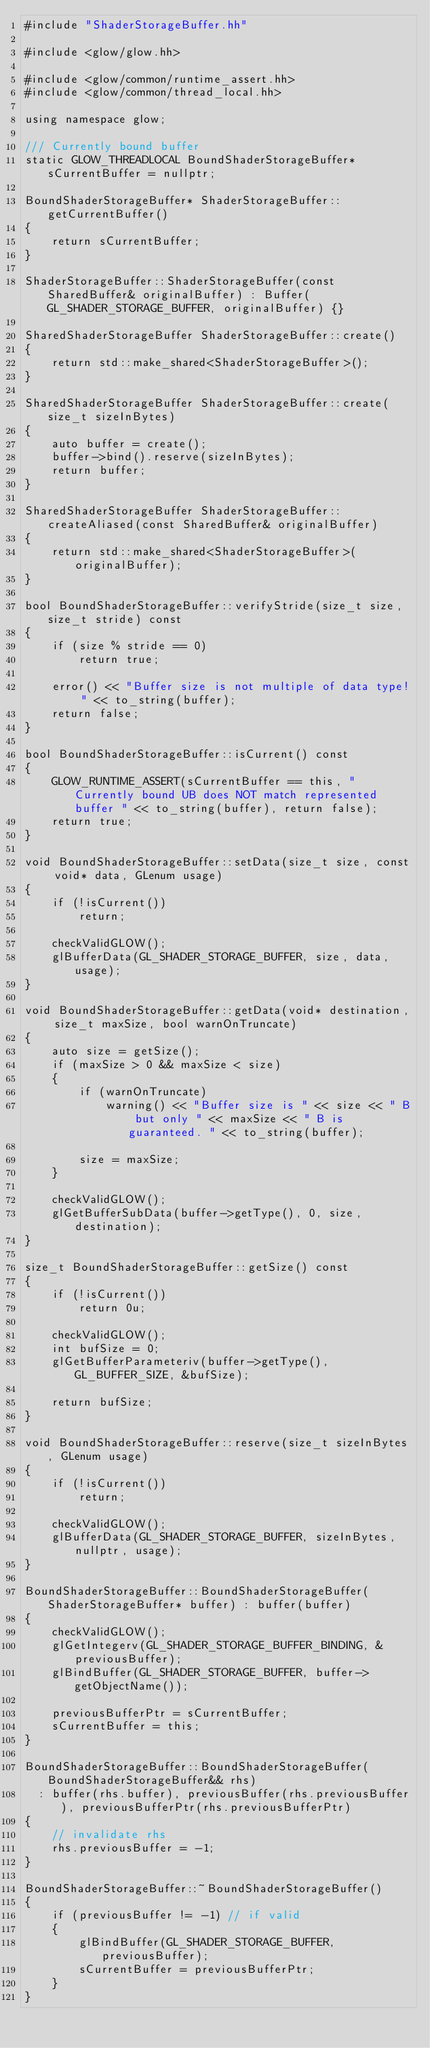<code> <loc_0><loc_0><loc_500><loc_500><_C++_>#include "ShaderStorageBuffer.hh"

#include <glow/glow.hh>

#include <glow/common/runtime_assert.hh>
#include <glow/common/thread_local.hh>

using namespace glow;

/// Currently bound buffer
static GLOW_THREADLOCAL BoundShaderStorageBuffer* sCurrentBuffer = nullptr;

BoundShaderStorageBuffer* ShaderStorageBuffer::getCurrentBuffer()
{
    return sCurrentBuffer;
}

ShaderStorageBuffer::ShaderStorageBuffer(const SharedBuffer& originalBuffer) : Buffer(GL_SHADER_STORAGE_BUFFER, originalBuffer) {}

SharedShaderStorageBuffer ShaderStorageBuffer::create()
{
    return std::make_shared<ShaderStorageBuffer>();
}

SharedShaderStorageBuffer ShaderStorageBuffer::create(size_t sizeInBytes)
{
    auto buffer = create();
    buffer->bind().reserve(sizeInBytes);
    return buffer;
}

SharedShaderStorageBuffer ShaderStorageBuffer::createAliased(const SharedBuffer& originalBuffer)
{
    return std::make_shared<ShaderStorageBuffer>(originalBuffer);
}

bool BoundShaderStorageBuffer::verifyStride(size_t size, size_t stride) const
{
    if (size % stride == 0)
        return true;

    error() << "Buffer size is not multiple of data type! " << to_string(buffer);
    return false;
}

bool BoundShaderStorageBuffer::isCurrent() const
{
    GLOW_RUNTIME_ASSERT(sCurrentBuffer == this, "Currently bound UB does NOT match represented buffer " << to_string(buffer), return false);
    return true;
}

void BoundShaderStorageBuffer::setData(size_t size, const void* data, GLenum usage)
{
    if (!isCurrent())
        return;

    checkValidGLOW();
    glBufferData(GL_SHADER_STORAGE_BUFFER, size, data, usage);
}

void BoundShaderStorageBuffer::getData(void* destination, size_t maxSize, bool warnOnTruncate)
{
    auto size = getSize();
    if (maxSize > 0 && maxSize < size)
    {
        if (warnOnTruncate)
            warning() << "Buffer size is " << size << " B but only " << maxSize << " B is guaranteed. " << to_string(buffer);

        size = maxSize;
    }

    checkValidGLOW();
    glGetBufferSubData(buffer->getType(), 0, size, destination);
}

size_t BoundShaderStorageBuffer::getSize() const
{
    if (!isCurrent())
        return 0u;

    checkValidGLOW();
    int bufSize = 0;
    glGetBufferParameteriv(buffer->getType(), GL_BUFFER_SIZE, &bufSize);

    return bufSize;
}

void BoundShaderStorageBuffer::reserve(size_t sizeInBytes, GLenum usage)
{
    if (!isCurrent())
        return;

    checkValidGLOW();
    glBufferData(GL_SHADER_STORAGE_BUFFER, sizeInBytes, nullptr, usage);
}

BoundShaderStorageBuffer::BoundShaderStorageBuffer(ShaderStorageBuffer* buffer) : buffer(buffer)
{
    checkValidGLOW();
    glGetIntegerv(GL_SHADER_STORAGE_BUFFER_BINDING, &previousBuffer);
    glBindBuffer(GL_SHADER_STORAGE_BUFFER, buffer->getObjectName());

    previousBufferPtr = sCurrentBuffer;
    sCurrentBuffer = this;
}

BoundShaderStorageBuffer::BoundShaderStorageBuffer(BoundShaderStorageBuffer&& rhs)
  : buffer(rhs.buffer), previousBuffer(rhs.previousBuffer), previousBufferPtr(rhs.previousBufferPtr)
{
    // invalidate rhs
    rhs.previousBuffer = -1;
}

BoundShaderStorageBuffer::~BoundShaderStorageBuffer()
{
    if (previousBuffer != -1) // if valid
    {
        glBindBuffer(GL_SHADER_STORAGE_BUFFER, previousBuffer);
        sCurrentBuffer = previousBufferPtr;
    }
}
</code> 